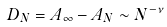Convert formula to latex. <formula><loc_0><loc_0><loc_500><loc_500>D _ { N } = A _ { \infty } - A _ { N } \sim N ^ { - \nu }</formula> 